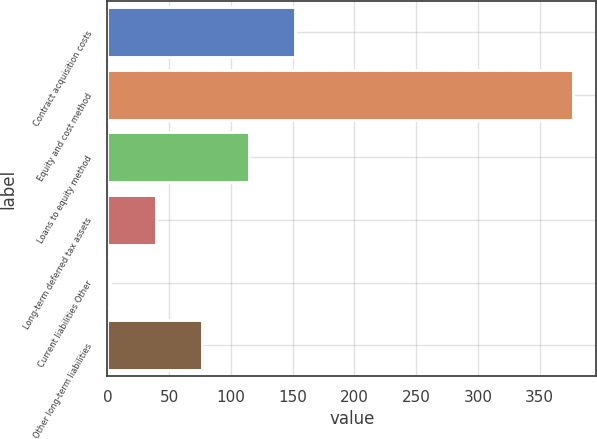<chart> <loc_0><loc_0><loc_500><loc_500><bar_chart><fcel>Contract acquisition costs<fcel>Equity and cost method<fcel>Loans to equity method<fcel>Long-term deferred tax assets<fcel>Current liabilities Other<fcel>Other long-term liabilities<nl><fcel>152<fcel>377<fcel>114.5<fcel>39.5<fcel>2<fcel>77<nl></chart> 